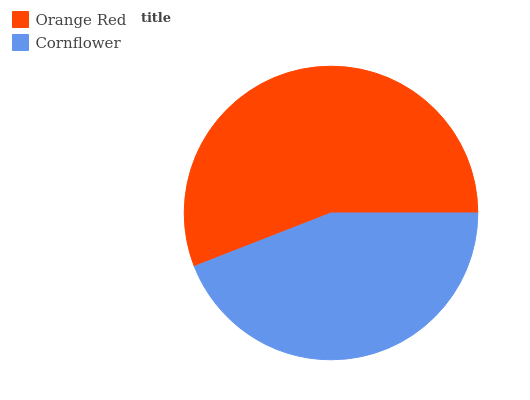Is Cornflower the minimum?
Answer yes or no. Yes. Is Orange Red the maximum?
Answer yes or no. Yes. Is Cornflower the maximum?
Answer yes or no. No. Is Orange Red greater than Cornflower?
Answer yes or no. Yes. Is Cornflower less than Orange Red?
Answer yes or no. Yes. Is Cornflower greater than Orange Red?
Answer yes or no. No. Is Orange Red less than Cornflower?
Answer yes or no. No. Is Orange Red the high median?
Answer yes or no. Yes. Is Cornflower the low median?
Answer yes or no. Yes. Is Cornflower the high median?
Answer yes or no. No. Is Orange Red the low median?
Answer yes or no. No. 